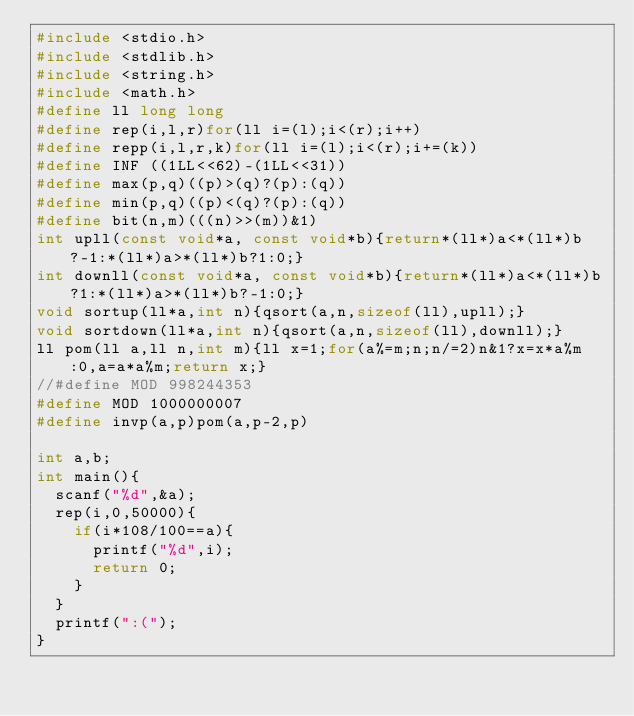Convert code to text. <code><loc_0><loc_0><loc_500><loc_500><_C_>#include <stdio.h>
#include <stdlib.h>
#include <string.h>
#include <math.h>
#define ll long long
#define rep(i,l,r)for(ll i=(l);i<(r);i++)
#define repp(i,l,r,k)for(ll i=(l);i<(r);i+=(k))
#define INF ((1LL<<62)-(1LL<<31))
#define max(p,q)((p)>(q)?(p):(q))
#define min(p,q)((p)<(q)?(p):(q))
#define bit(n,m)(((n)>>(m))&1)
int upll(const void*a, const void*b){return*(ll*)a<*(ll*)b?-1:*(ll*)a>*(ll*)b?1:0;}
int downll(const void*a, const void*b){return*(ll*)a<*(ll*)b?1:*(ll*)a>*(ll*)b?-1:0;}
void sortup(ll*a,int n){qsort(a,n,sizeof(ll),upll);}
void sortdown(ll*a,int n){qsort(a,n,sizeof(ll),downll);}
ll pom(ll a,ll n,int m){ll x=1;for(a%=m;n;n/=2)n&1?x=x*a%m:0,a=a*a%m;return x;}
//#define MOD 998244353
#define MOD 1000000007
#define invp(a,p)pom(a,p-2,p)

int a,b;
int main(){
	scanf("%d",&a);
	rep(i,0,50000){
		if(i*108/100==a){
			printf("%d",i);
			return 0;
		}
	}
	printf(":(");
}</code> 